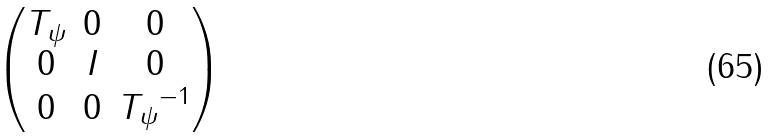<formula> <loc_0><loc_0><loc_500><loc_500>\begin{pmatrix} T _ { \psi } & 0 & 0 \\ 0 & I & 0 \\ 0 & 0 & { T _ { \psi } } ^ { - 1 } \end{pmatrix}</formula> 